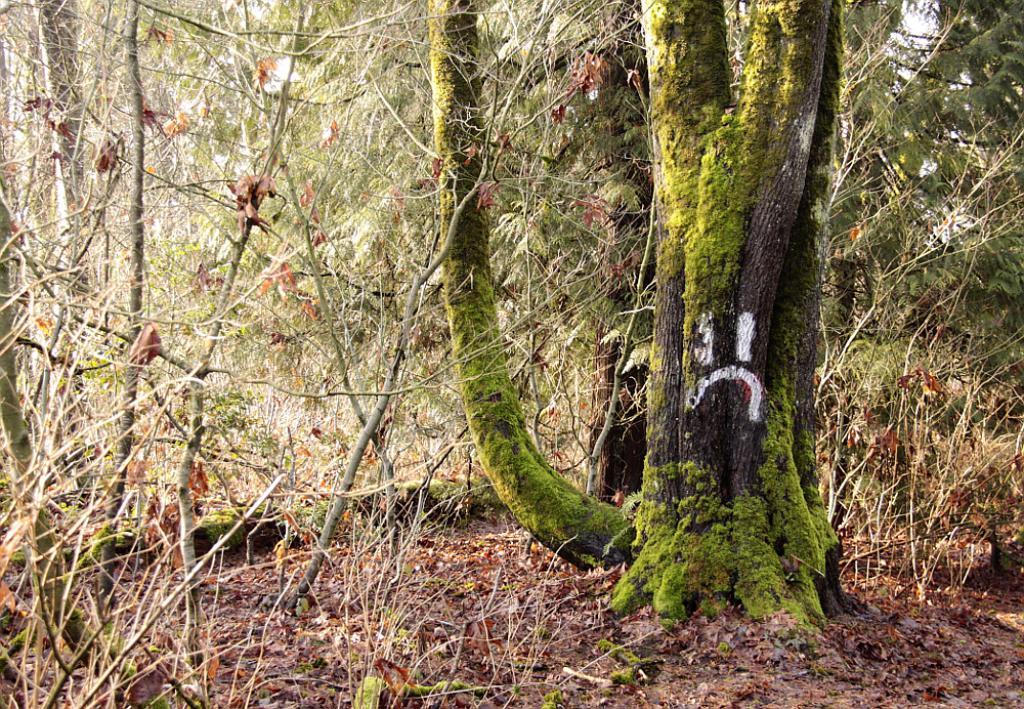What type of vegetation can be seen in the image? There is a group of trees in the image. Are there any specific features on the trees? Yes, the bark of a tree has some painting on it. What else can be found on the ground in the image? There are dried leaves in the image. What is visible in the background of the image? The sky is visible in the image. How many brothers are depicted in the image? There are no brothers present in the image; it features a group of trees with painted bark and dried leaves on the ground. What type of cow can be seen grazing in the image? There is no cow present in the image; it only contains trees, painted bark, dried leaves, and the sky. 